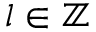Convert formula to latex. <formula><loc_0><loc_0><loc_500><loc_500>l \in { \mathbb { Z } }</formula> 